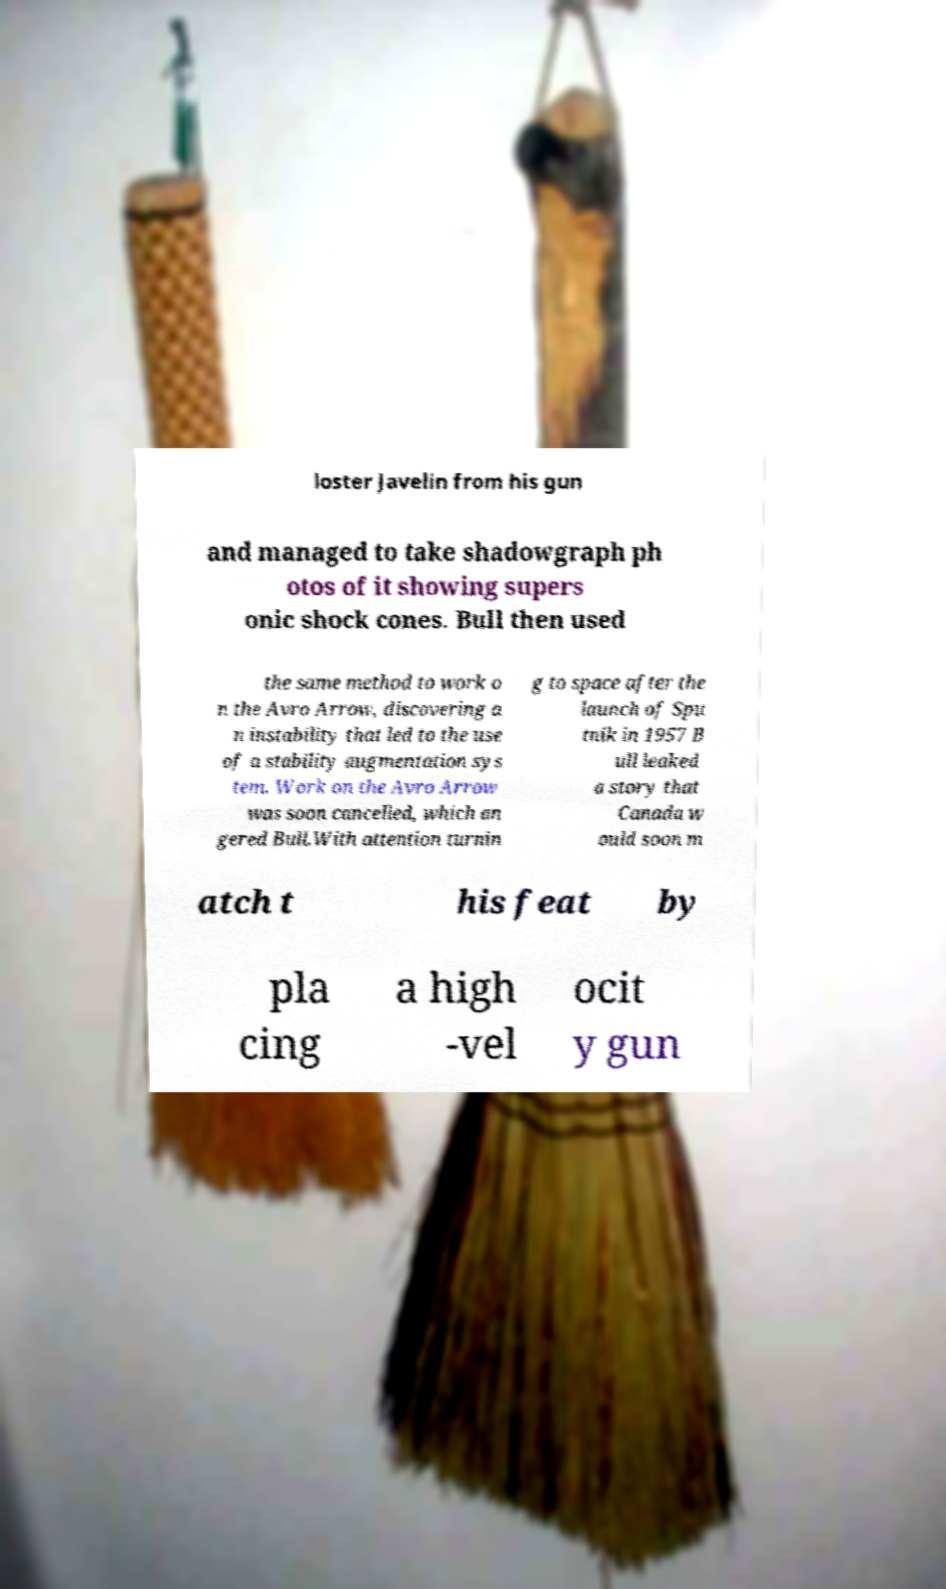Can you accurately transcribe the text from the provided image for me? loster Javelin from his gun and managed to take shadowgraph ph otos of it showing supers onic shock cones. Bull then used the same method to work o n the Avro Arrow, discovering a n instability that led to the use of a stability augmentation sys tem. Work on the Avro Arrow was soon cancelled, which an gered Bull.With attention turnin g to space after the launch of Spu tnik in 1957 B ull leaked a story that Canada w ould soon m atch t his feat by pla cing a high -vel ocit y gun 